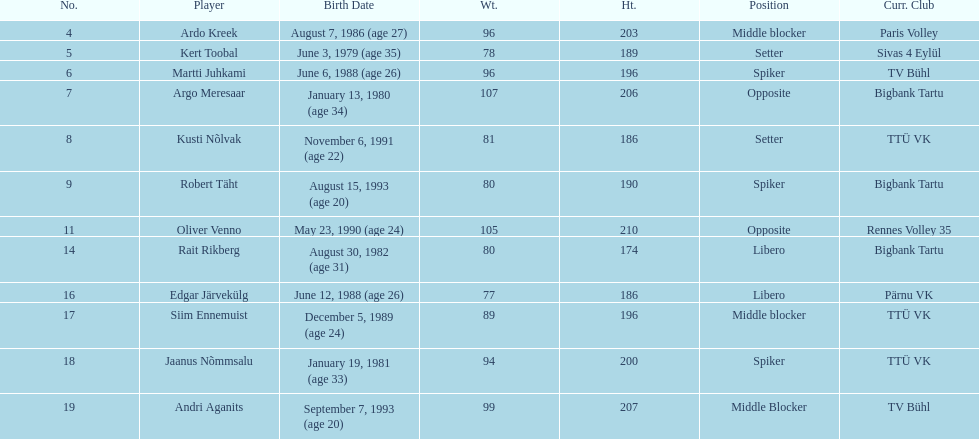What are the total number of players from france? 2. 